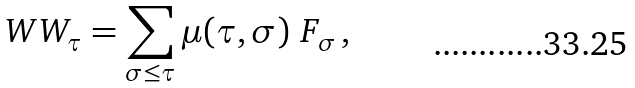Convert formula to latex. <formula><loc_0><loc_0><loc_500><loc_500>\ W W _ { \tau } = \sum _ { \sigma \leq \tau } \mu ( \tau , \sigma ) \ F _ { \sigma } \, ,</formula> 